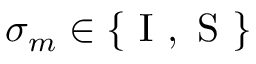Convert formula to latex. <formula><loc_0><loc_0><loc_500><loc_500>\sigma _ { m } \in \{ I , S \}</formula> 